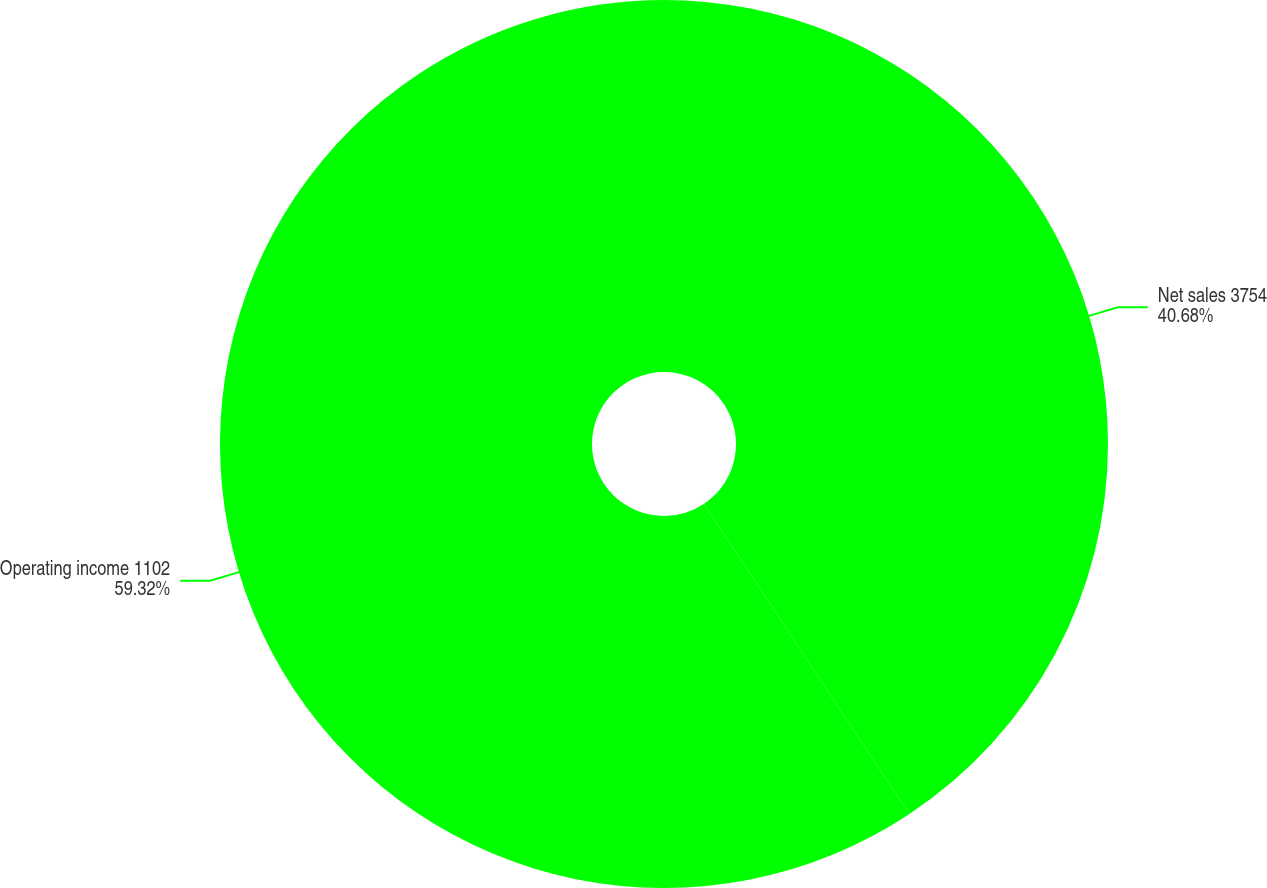Convert chart. <chart><loc_0><loc_0><loc_500><loc_500><pie_chart><fcel>Net sales 3754<fcel>Operating income 1102<nl><fcel>40.68%<fcel>59.32%<nl></chart> 